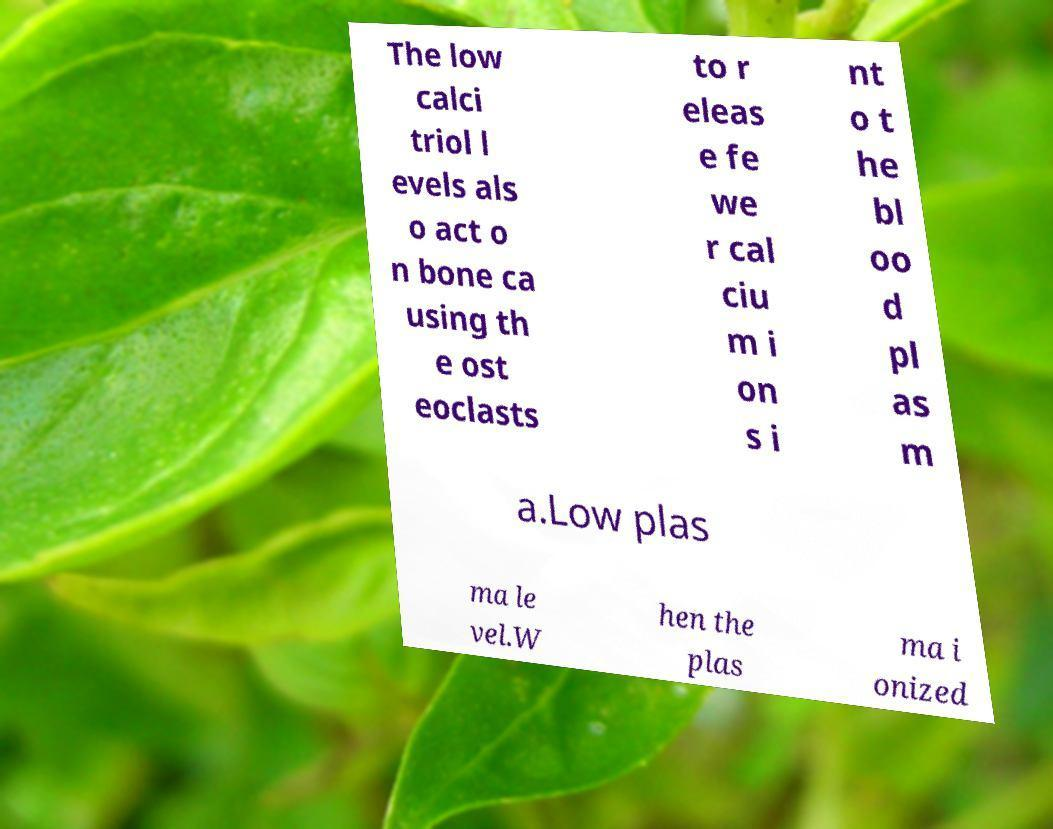I need the written content from this picture converted into text. Can you do that? The low calci triol l evels als o act o n bone ca using th e ost eoclasts to r eleas e fe we r cal ciu m i on s i nt o t he bl oo d pl as m a.Low plas ma le vel.W hen the plas ma i onized 